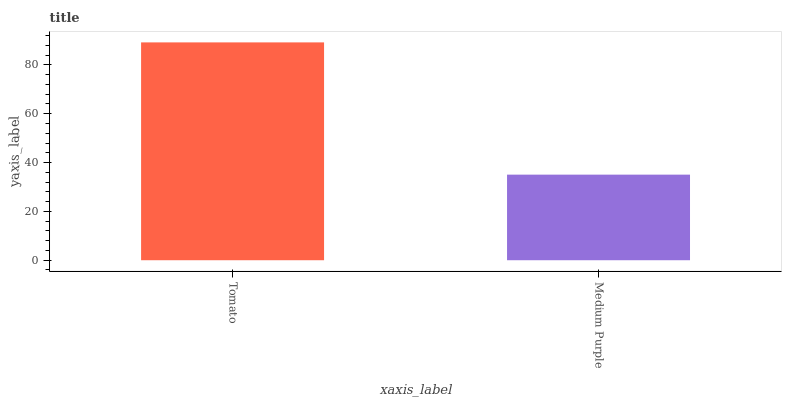Is Medium Purple the minimum?
Answer yes or no. Yes. Is Tomato the maximum?
Answer yes or no. Yes. Is Medium Purple the maximum?
Answer yes or no. No. Is Tomato greater than Medium Purple?
Answer yes or no. Yes. Is Medium Purple less than Tomato?
Answer yes or no. Yes. Is Medium Purple greater than Tomato?
Answer yes or no. No. Is Tomato less than Medium Purple?
Answer yes or no. No. Is Tomato the high median?
Answer yes or no. Yes. Is Medium Purple the low median?
Answer yes or no. Yes. Is Medium Purple the high median?
Answer yes or no. No. Is Tomato the low median?
Answer yes or no. No. 